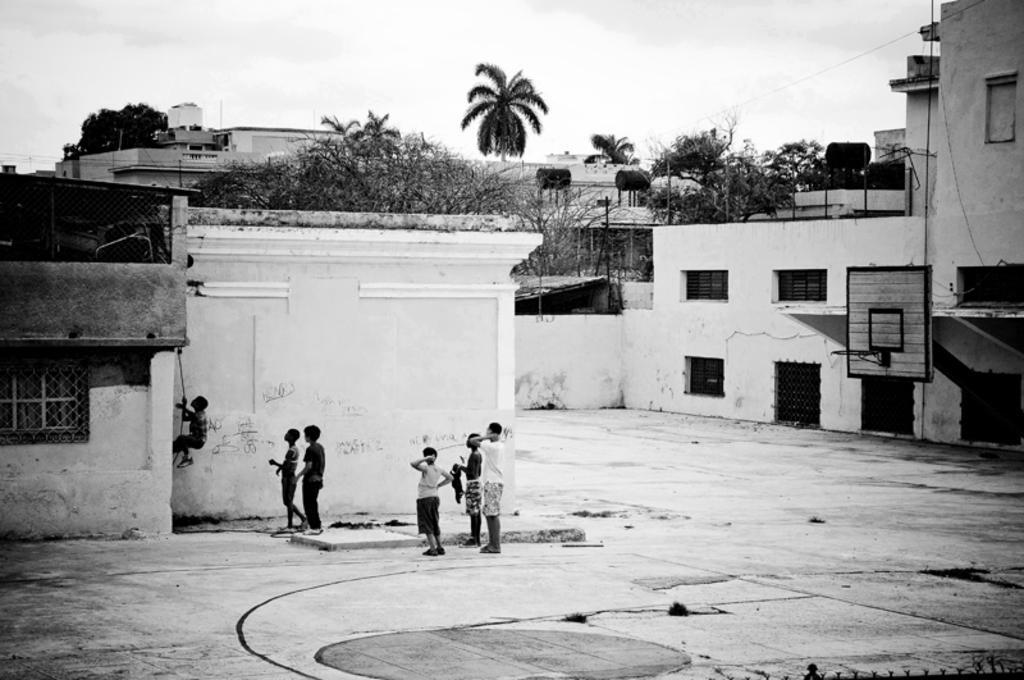Please provide a concise description of this image. This is a black and white image. In the center of the image we can see some people are standing. On the left side of the image we can see a boy is climbing a house. In the background of the image we can see the buildings, windows, houses, trees, solar water heaters, volleyball court. At the bottom of the image we can see the ground. At the top of the image we can see the sky. 